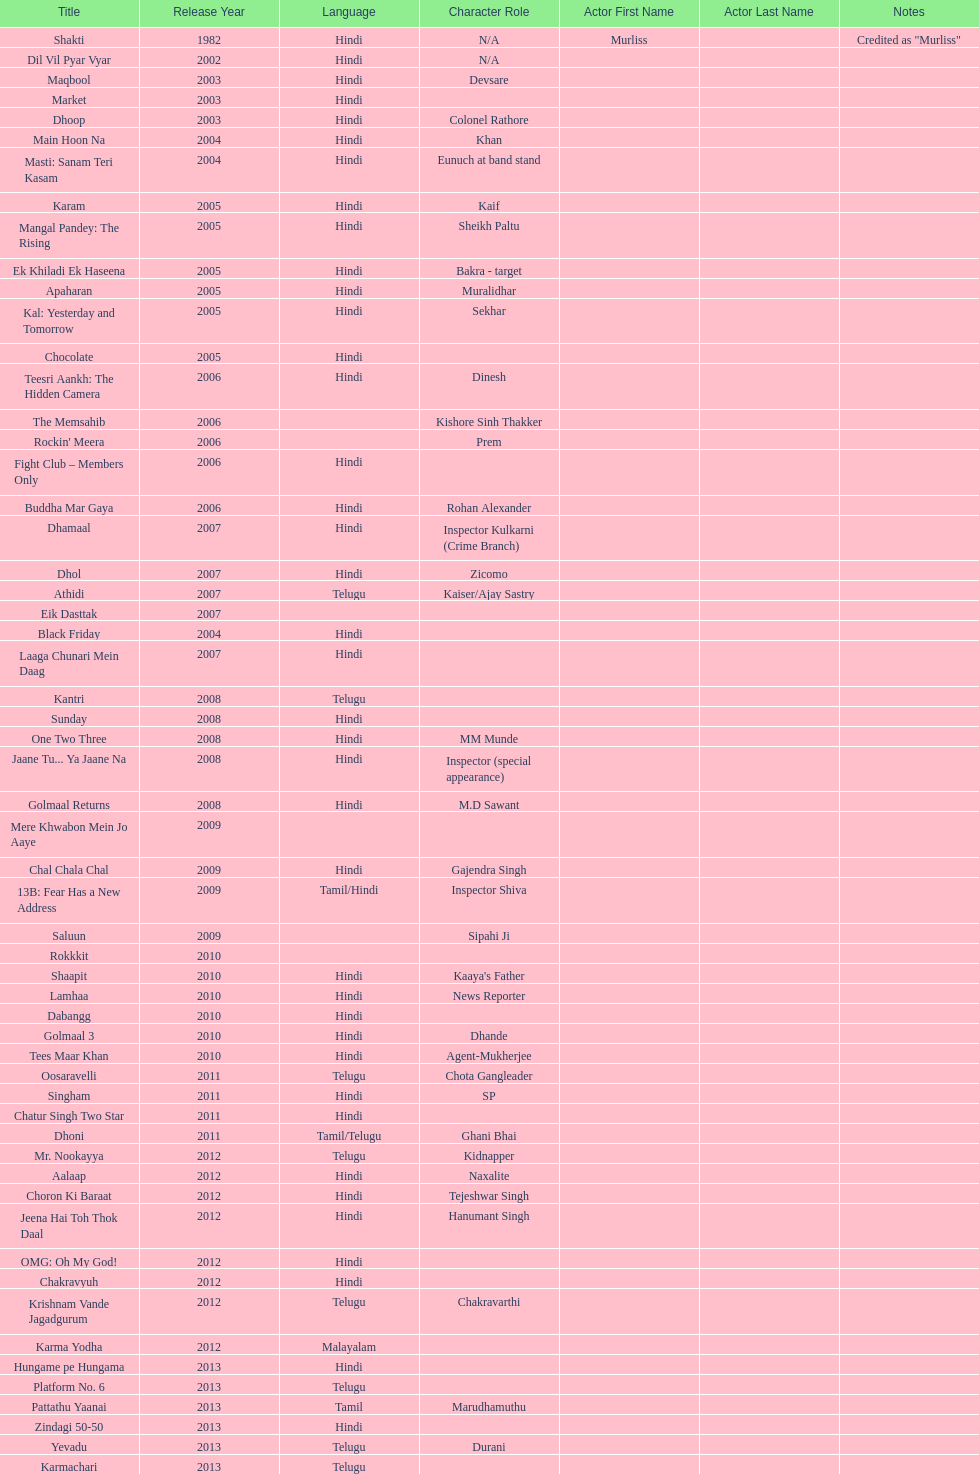What is the first language after hindi Telugu. 